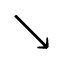Convert formula to latex. <formula><loc_0><loc_0><loc_500><loc_500>\searrow</formula> 